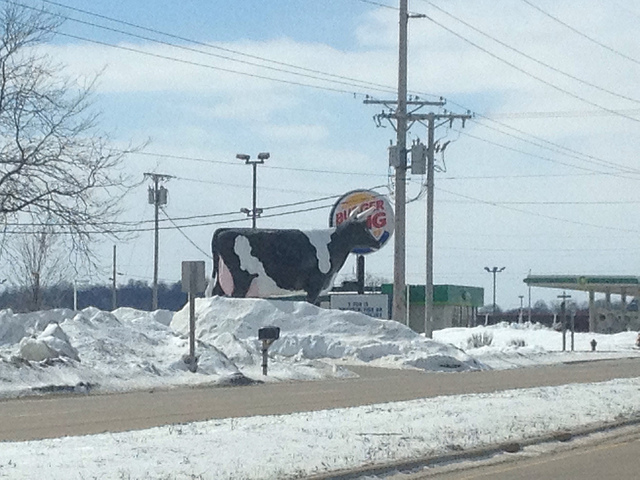Identify and read out the text in this image. BU G 